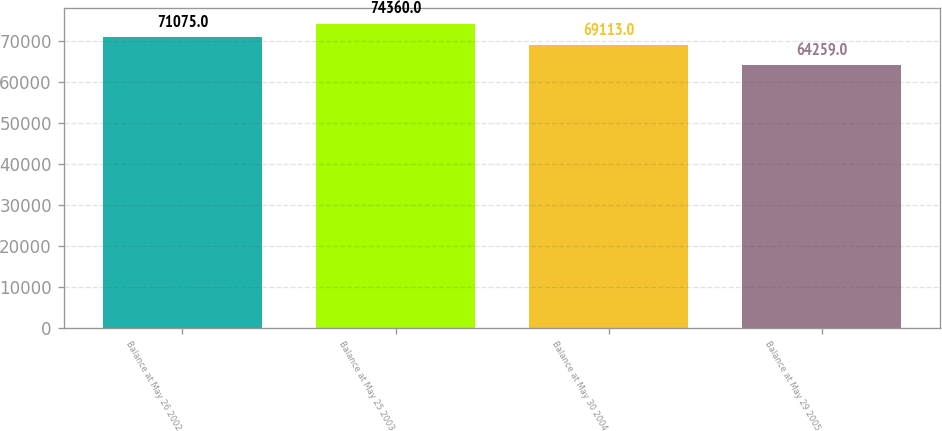<chart> <loc_0><loc_0><loc_500><loc_500><bar_chart><fcel>Balance at May 26 2002<fcel>Balance at May 25 2003<fcel>Balance at May 30 2004<fcel>Balance at May 29 2005<nl><fcel>71075<fcel>74360<fcel>69113<fcel>64259<nl></chart> 